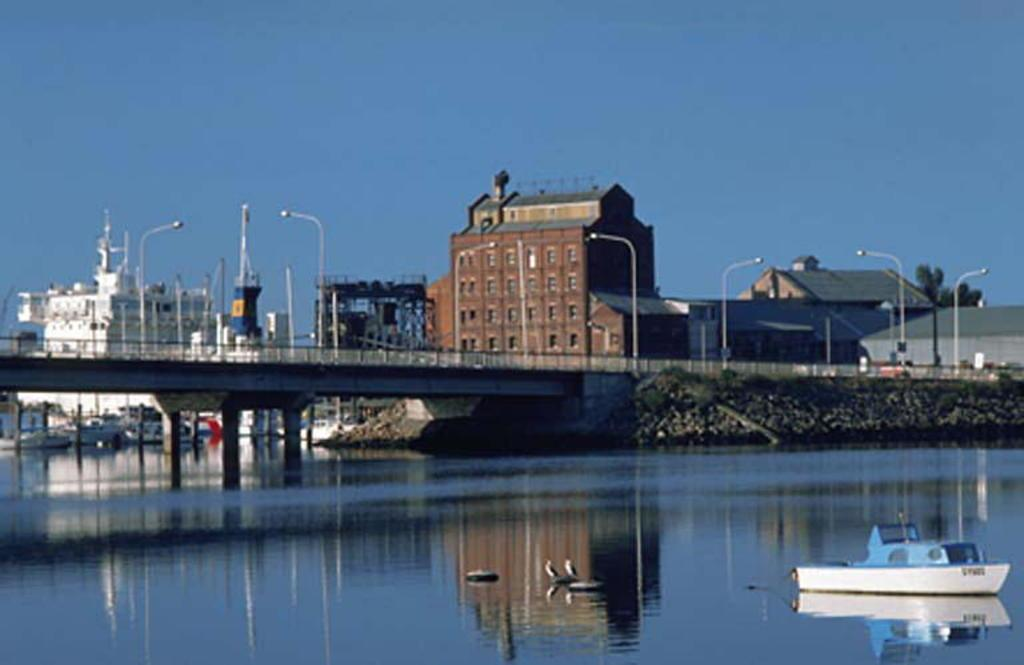What is the main subject of the image? The main subject of the image is a boat. What can be seen on the water in the image? There are birds on the water in the image. What architectural feature is present in the image? There is a bridge in the image. What structural elements are visible in the image? There are pillars in the image. What type of man-made structures can be seen in the image? There are buildings in the image. What other objects are present in the image? There is a pole in the image. What type of natural elements are present in the image? There are trees in the image. What can be seen in the background of the image? The sky is visible in the background of the image. What type of crime is being committed in the image? There is no indication of any crime being committed in the image. What type of art can be seen in the image? There is no art present in the image; it features a boat, birds, a bridge, pillars, buildings, a pole, trees, and the sky. How many geese are visible in the image? There are no geese present in the image; it features birds, but their specific type is not mentioned. 